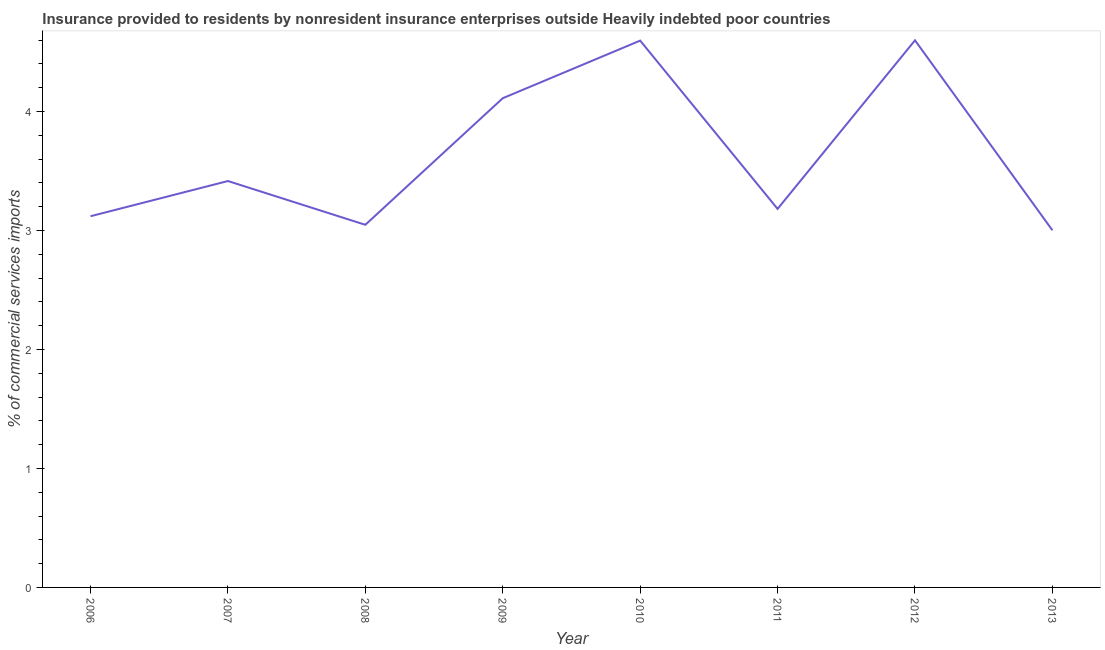What is the insurance provided by non-residents in 2006?
Give a very brief answer. 3.12. Across all years, what is the maximum insurance provided by non-residents?
Your answer should be compact. 4.6. Across all years, what is the minimum insurance provided by non-residents?
Make the answer very short. 3. In which year was the insurance provided by non-residents maximum?
Your answer should be compact. 2012. In which year was the insurance provided by non-residents minimum?
Your answer should be compact. 2013. What is the sum of the insurance provided by non-residents?
Give a very brief answer. 29.07. What is the difference between the insurance provided by non-residents in 2007 and 2013?
Your answer should be very brief. 0.41. What is the average insurance provided by non-residents per year?
Keep it short and to the point. 3.63. What is the median insurance provided by non-residents?
Provide a succinct answer. 3.3. In how many years, is the insurance provided by non-residents greater than 3.4 %?
Your answer should be compact. 4. Do a majority of the years between 2010 and 2006 (inclusive) have insurance provided by non-residents greater than 4.2 %?
Your answer should be very brief. Yes. What is the ratio of the insurance provided by non-residents in 2006 to that in 2013?
Offer a terse response. 1.04. Is the insurance provided by non-residents in 2011 less than that in 2013?
Your answer should be very brief. No. What is the difference between the highest and the second highest insurance provided by non-residents?
Your answer should be compact. 0. What is the difference between the highest and the lowest insurance provided by non-residents?
Offer a terse response. 1.6. Does the insurance provided by non-residents monotonically increase over the years?
Keep it short and to the point. No. How many years are there in the graph?
Your answer should be compact. 8. Does the graph contain grids?
Provide a short and direct response. No. What is the title of the graph?
Your answer should be compact. Insurance provided to residents by nonresident insurance enterprises outside Heavily indebted poor countries. What is the label or title of the Y-axis?
Provide a succinct answer. % of commercial services imports. What is the % of commercial services imports of 2006?
Ensure brevity in your answer.  3.12. What is the % of commercial services imports of 2007?
Offer a very short reply. 3.42. What is the % of commercial services imports in 2008?
Make the answer very short. 3.05. What is the % of commercial services imports in 2009?
Your answer should be very brief. 4.11. What is the % of commercial services imports in 2010?
Provide a succinct answer. 4.6. What is the % of commercial services imports of 2011?
Provide a short and direct response. 3.18. What is the % of commercial services imports in 2012?
Offer a very short reply. 4.6. What is the % of commercial services imports in 2013?
Offer a very short reply. 3. What is the difference between the % of commercial services imports in 2006 and 2007?
Your response must be concise. -0.3. What is the difference between the % of commercial services imports in 2006 and 2008?
Offer a very short reply. 0.07. What is the difference between the % of commercial services imports in 2006 and 2009?
Your answer should be compact. -0.99. What is the difference between the % of commercial services imports in 2006 and 2010?
Your answer should be very brief. -1.48. What is the difference between the % of commercial services imports in 2006 and 2011?
Provide a succinct answer. -0.06. What is the difference between the % of commercial services imports in 2006 and 2012?
Your answer should be compact. -1.48. What is the difference between the % of commercial services imports in 2006 and 2013?
Your answer should be very brief. 0.12. What is the difference between the % of commercial services imports in 2007 and 2008?
Provide a succinct answer. 0.37. What is the difference between the % of commercial services imports in 2007 and 2009?
Give a very brief answer. -0.7. What is the difference between the % of commercial services imports in 2007 and 2010?
Provide a short and direct response. -1.18. What is the difference between the % of commercial services imports in 2007 and 2011?
Keep it short and to the point. 0.23. What is the difference between the % of commercial services imports in 2007 and 2012?
Your answer should be compact. -1.18. What is the difference between the % of commercial services imports in 2007 and 2013?
Give a very brief answer. 0.41. What is the difference between the % of commercial services imports in 2008 and 2009?
Ensure brevity in your answer.  -1.06. What is the difference between the % of commercial services imports in 2008 and 2010?
Give a very brief answer. -1.55. What is the difference between the % of commercial services imports in 2008 and 2011?
Give a very brief answer. -0.13. What is the difference between the % of commercial services imports in 2008 and 2012?
Provide a succinct answer. -1.55. What is the difference between the % of commercial services imports in 2008 and 2013?
Keep it short and to the point. 0.05. What is the difference between the % of commercial services imports in 2009 and 2010?
Provide a short and direct response. -0.48. What is the difference between the % of commercial services imports in 2009 and 2011?
Your response must be concise. 0.93. What is the difference between the % of commercial services imports in 2009 and 2012?
Ensure brevity in your answer.  -0.49. What is the difference between the % of commercial services imports in 2009 and 2013?
Provide a short and direct response. 1.11. What is the difference between the % of commercial services imports in 2010 and 2011?
Provide a succinct answer. 1.41. What is the difference between the % of commercial services imports in 2010 and 2012?
Your answer should be very brief. -0. What is the difference between the % of commercial services imports in 2010 and 2013?
Offer a very short reply. 1.59. What is the difference between the % of commercial services imports in 2011 and 2012?
Keep it short and to the point. -1.42. What is the difference between the % of commercial services imports in 2011 and 2013?
Your answer should be compact. 0.18. What is the difference between the % of commercial services imports in 2012 and 2013?
Offer a very short reply. 1.6. What is the ratio of the % of commercial services imports in 2006 to that in 2008?
Offer a terse response. 1.02. What is the ratio of the % of commercial services imports in 2006 to that in 2009?
Give a very brief answer. 0.76. What is the ratio of the % of commercial services imports in 2006 to that in 2010?
Give a very brief answer. 0.68. What is the ratio of the % of commercial services imports in 2006 to that in 2011?
Your response must be concise. 0.98. What is the ratio of the % of commercial services imports in 2006 to that in 2012?
Make the answer very short. 0.68. What is the ratio of the % of commercial services imports in 2006 to that in 2013?
Your response must be concise. 1.04. What is the ratio of the % of commercial services imports in 2007 to that in 2008?
Your response must be concise. 1.12. What is the ratio of the % of commercial services imports in 2007 to that in 2009?
Make the answer very short. 0.83. What is the ratio of the % of commercial services imports in 2007 to that in 2010?
Your answer should be very brief. 0.74. What is the ratio of the % of commercial services imports in 2007 to that in 2011?
Keep it short and to the point. 1.07. What is the ratio of the % of commercial services imports in 2007 to that in 2012?
Provide a short and direct response. 0.74. What is the ratio of the % of commercial services imports in 2007 to that in 2013?
Ensure brevity in your answer.  1.14. What is the ratio of the % of commercial services imports in 2008 to that in 2009?
Provide a succinct answer. 0.74. What is the ratio of the % of commercial services imports in 2008 to that in 2010?
Make the answer very short. 0.66. What is the ratio of the % of commercial services imports in 2008 to that in 2011?
Keep it short and to the point. 0.96. What is the ratio of the % of commercial services imports in 2008 to that in 2012?
Your answer should be very brief. 0.66. What is the ratio of the % of commercial services imports in 2009 to that in 2010?
Your answer should be very brief. 0.9. What is the ratio of the % of commercial services imports in 2009 to that in 2011?
Provide a succinct answer. 1.29. What is the ratio of the % of commercial services imports in 2009 to that in 2012?
Provide a short and direct response. 0.89. What is the ratio of the % of commercial services imports in 2009 to that in 2013?
Give a very brief answer. 1.37. What is the ratio of the % of commercial services imports in 2010 to that in 2011?
Give a very brief answer. 1.44. What is the ratio of the % of commercial services imports in 2010 to that in 2013?
Your answer should be very brief. 1.53. What is the ratio of the % of commercial services imports in 2011 to that in 2012?
Your answer should be very brief. 0.69. What is the ratio of the % of commercial services imports in 2011 to that in 2013?
Offer a very short reply. 1.06. What is the ratio of the % of commercial services imports in 2012 to that in 2013?
Make the answer very short. 1.53. 